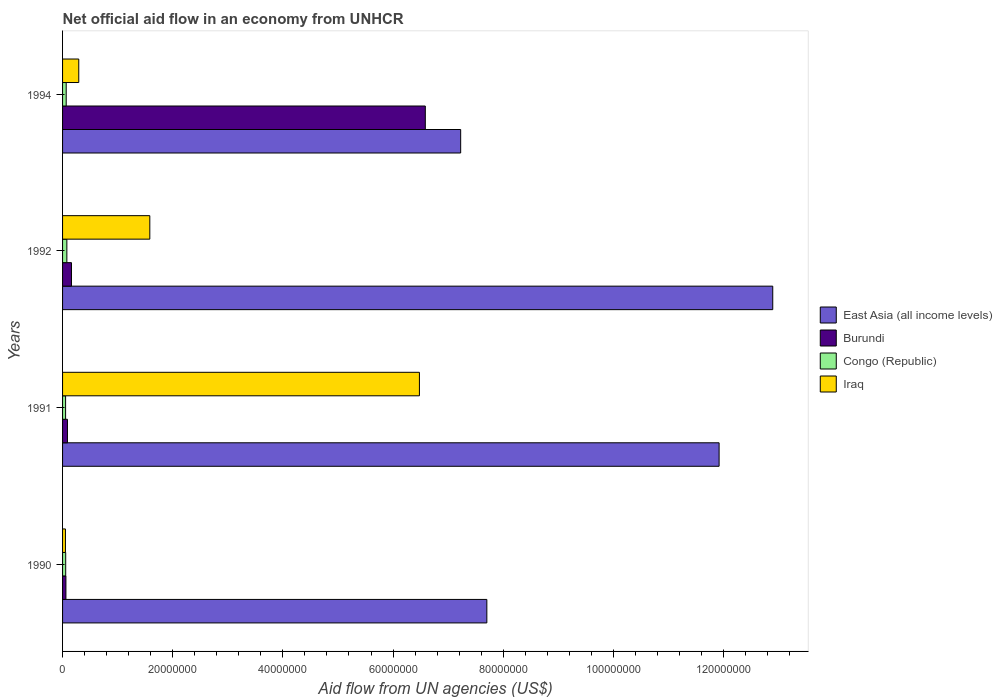How many groups of bars are there?
Offer a very short reply. 4. What is the net official aid flow in Burundi in 1994?
Your answer should be compact. 6.59e+07. Across all years, what is the maximum net official aid flow in Burundi?
Your answer should be very brief. 6.59e+07. Across all years, what is the minimum net official aid flow in East Asia (all income levels)?
Give a very brief answer. 7.23e+07. In which year was the net official aid flow in East Asia (all income levels) maximum?
Keep it short and to the point. 1992. What is the total net official aid flow in Iraq in the graph?
Give a very brief answer. 8.41e+07. What is the difference between the net official aid flow in Iraq in 1990 and that in 1991?
Your response must be concise. -6.43e+07. What is the difference between the net official aid flow in Congo (Republic) in 1994 and the net official aid flow in East Asia (all income levels) in 1991?
Offer a terse response. -1.19e+08. What is the average net official aid flow in Iraq per year?
Keep it short and to the point. 2.10e+07. In the year 1992, what is the difference between the net official aid flow in Iraq and net official aid flow in Burundi?
Your answer should be compact. 1.42e+07. What is the ratio of the net official aid flow in Iraq in 1990 to that in 1991?
Provide a succinct answer. 0.01. Is the net official aid flow in Burundi in 1990 less than that in 1994?
Your answer should be compact. Yes. What is the difference between the highest and the second highest net official aid flow in East Asia (all income levels)?
Ensure brevity in your answer.  9.74e+06. In how many years, is the net official aid flow in Burundi greater than the average net official aid flow in Burundi taken over all years?
Offer a terse response. 1. What does the 2nd bar from the top in 1990 represents?
Give a very brief answer. Congo (Republic). What does the 4th bar from the bottom in 1990 represents?
Your response must be concise. Iraq. How many bars are there?
Provide a short and direct response. 16. Are all the bars in the graph horizontal?
Give a very brief answer. Yes. What is the difference between two consecutive major ticks on the X-axis?
Your answer should be compact. 2.00e+07. How are the legend labels stacked?
Provide a short and direct response. Vertical. What is the title of the graph?
Provide a succinct answer. Net official aid flow in an economy from UNHCR. Does "Isle of Man" appear as one of the legend labels in the graph?
Provide a succinct answer. No. What is the label or title of the X-axis?
Provide a succinct answer. Aid flow from UN agencies (US$). What is the Aid flow from UN agencies (US$) of East Asia (all income levels) in 1990?
Keep it short and to the point. 7.70e+07. What is the Aid flow from UN agencies (US$) of Congo (Republic) in 1990?
Keep it short and to the point. 5.70e+05. What is the Aid flow from UN agencies (US$) of Iraq in 1990?
Your response must be concise. 5.20e+05. What is the Aid flow from UN agencies (US$) in East Asia (all income levels) in 1991?
Provide a succinct answer. 1.19e+08. What is the Aid flow from UN agencies (US$) in Burundi in 1991?
Offer a terse response. 8.90e+05. What is the Aid flow from UN agencies (US$) of Iraq in 1991?
Your response must be concise. 6.48e+07. What is the Aid flow from UN agencies (US$) in East Asia (all income levels) in 1992?
Offer a terse response. 1.29e+08. What is the Aid flow from UN agencies (US$) in Burundi in 1992?
Keep it short and to the point. 1.62e+06. What is the Aid flow from UN agencies (US$) in Congo (Republic) in 1992?
Provide a succinct answer. 7.80e+05. What is the Aid flow from UN agencies (US$) in Iraq in 1992?
Provide a succinct answer. 1.58e+07. What is the Aid flow from UN agencies (US$) in East Asia (all income levels) in 1994?
Provide a succinct answer. 7.23e+07. What is the Aid flow from UN agencies (US$) of Burundi in 1994?
Offer a terse response. 6.59e+07. What is the Aid flow from UN agencies (US$) in Iraq in 1994?
Provide a short and direct response. 2.94e+06. Across all years, what is the maximum Aid flow from UN agencies (US$) in East Asia (all income levels)?
Your answer should be compact. 1.29e+08. Across all years, what is the maximum Aid flow from UN agencies (US$) in Burundi?
Keep it short and to the point. 6.59e+07. Across all years, what is the maximum Aid flow from UN agencies (US$) of Congo (Republic)?
Give a very brief answer. 7.80e+05. Across all years, what is the maximum Aid flow from UN agencies (US$) in Iraq?
Offer a very short reply. 6.48e+07. Across all years, what is the minimum Aid flow from UN agencies (US$) of East Asia (all income levels)?
Make the answer very short. 7.23e+07. Across all years, what is the minimum Aid flow from UN agencies (US$) of Burundi?
Your answer should be compact. 6.10e+05. Across all years, what is the minimum Aid flow from UN agencies (US$) of Iraq?
Make the answer very short. 5.20e+05. What is the total Aid flow from UN agencies (US$) of East Asia (all income levels) in the graph?
Offer a very short reply. 3.97e+08. What is the total Aid flow from UN agencies (US$) of Burundi in the graph?
Give a very brief answer. 6.90e+07. What is the total Aid flow from UN agencies (US$) in Congo (Republic) in the graph?
Provide a succinct answer. 2.56e+06. What is the total Aid flow from UN agencies (US$) of Iraq in the graph?
Provide a short and direct response. 8.41e+07. What is the difference between the Aid flow from UN agencies (US$) of East Asia (all income levels) in 1990 and that in 1991?
Provide a short and direct response. -4.22e+07. What is the difference between the Aid flow from UN agencies (US$) of Burundi in 1990 and that in 1991?
Your response must be concise. -2.80e+05. What is the difference between the Aid flow from UN agencies (US$) in Congo (Republic) in 1990 and that in 1991?
Offer a terse response. 2.00e+04. What is the difference between the Aid flow from UN agencies (US$) of Iraq in 1990 and that in 1991?
Offer a very short reply. -6.43e+07. What is the difference between the Aid flow from UN agencies (US$) in East Asia (all income levels) in 1990 and that in 1992?
Your answer should be very brief. -5.19e+07. What is the difference between the Aid flow from UN agencies (US$) in Burundi in 1990 and that in 1992?
Offer a terse response. -1.01e+06. What is the difference between the Aid flow from UN agencies (US$) of Congo (Republic) in 1990 and that in 1992?
Make the answer very short. -2.10e+05. What is the difference between the Aid flow from UN agencies (US$) in Iraq in 1990 and that in 1992?
Ensure brevity in your answer.  -1.53e+07. What is the difference between the Aid flow from UN agencies (US$) of East Asia (all income levels) in 1990 and that in 1994?
Your response must be concise. 4.75e+06. What is the difference between the Aid flow from UN agencies (US$) of Burundi in 1990 and that in 1994?
Your answer should be compact. -6.52e+07. What is the difference between the Aid flow from UN agencies (US$) of Congo (Republic) in 1990 and that in 1994?
Offer a terse response. -9.00e+04. What is the difference between the Aid flow from UN agencies (US$) of Iraq in 1990 and that in 1994?
Provide a short and direct response. -2.42e+06. What is the difference between the Aid flow from UN agencies (US$) in East Asia (all income levels) in 1991 and that in 1992?
Your answer should be very brief. -9.74e+06. What is the difference between the Aid flow from UN agencies (US$) in Burundi in 1991 and that in 1992?
Ensure brevity in your answer.  -7.30e+05. What is the difference between the Aid flow from UN agencies (US$) in Iraq in 1991 and that in 1992?
Offer a very short reply. 4.90e+07. What is the difference between the Aid flow from UN agencies (US$) of East Asia (all income levels) in 1991 and that in 1994?
Offer a terse response. 4.69e+07. What is the difference between the Aid flow from UN agencies (US$) of Burundi in 1991 and that in 1994?
Provide a short and direct response. -6.50e+07. What is the difference between the Aid flow from UN agencies (US$) in Iraq in 1991 and that in 1994?
Your response must be concise. 6.18e+07. What is the difference between the Aid flow from UN agencies (US$) in East Asia (all income levels) in 1992 and that in 1994?
Your answer should be compact. 5.67e+07. What is the difference between the Aid flow from UN agencies (US$) of Burundi in 1992 and that in 1994?
Your response must be concise. -6.42e+07. What is the difference between the Aid flow from UN agencies (US$) of Iraq in 1992 and that in 1994?
Keep it short and to the point. 1.29e+07. What is the difference between the Aid flow from UN agencies (US$) in East Asia (all income levels) in 1990 and the Aid flow from UN agencies (US$) in Burundi in 1991?
Offer a terse response. 7.61e+07. What is the difference between the Aid flow from UN agencies (US$) of East Asia (all income levels) in 1990 and the Aid flow from UN agencies (US$) of Congo (Republic) in 1991?
Your answer should be compact. 7.65e+07. What is the difference between the Aid flow from UN agencies (US$) in East Asia (all income levels) in 1990 and the Aid flow from UN agencies (US$) in Iraq in 1991?
Your response must be concise. 1.22e+07. What is the difference between the Aid flow from UN agencies (US$) in Burundi in 1990 and the Aid flow from UN agencies (US$) in Iraq in 1991?
Give a very brief answer. -6.42e+07. What is the difference between the Aid flow from UN agencies (US$) in Congo (Republic) in 1990 and the Aid flow from UN agencies (US$) in Iraq in 1991?
Offer a terse response. -6.42e+07. What is the difference between the Aid flow from UN agencies (US$) of East Asia (all income levels) in 1990 and the Aid flow from UN agencies (US$) of Burundi in 1992?
Offer a very short reply. 7.54e+07. What is the difference between the Aid flow from UN agencies (US$) of East Asia (all income levels) in 1990 and the Aid flow from UN agencies (US$) of Congo (Republic) in 1992?
Your answer should be very brief. 7.62e+07. What is the difference between the Aid flow from UN agencies (US$) in East Asia (all income levels) in 1990 and the Aid flow from UN agencies (US$) in Iraq in 1992?
Offer a very short reply. 6.12e+07. What is the difference between the Aid flow from UN agencies (US$) in Burundi in 1990 and the Aid flow from UN agencies (US$) in Congo (Republic) in 1992?
Offer a terse response. -1.70e+05. What is the difference between the Aid flow from UN agencies (US$) in Burundi in 1990 and the Aid flow from UN agencies (US$) in Iraq in 1992?
Offer a very short reply. -1.52e+07. What is the difference between the Aid flow from UN agencies (US$) in Congo (Republic) in 1990 and the Aid flow from UN agencies (US$) in Iraq in 1992?
Offer a very short reply. -1.53e+07. What is the difference between the Aid flow from UN agencies (US$) in East Asia (all income levels) in 1990 and the Aid flow from UN agencies (US$) in Burundi in 1994?
Your answer should be very brief. 1.12e+07. What is the difference between the Aid flow from UN agencies (US$) in East Asia (all income levels) in 1990 and the Aid flow from UN agencies (US$) in Congo (Republic) in 1994?
Keep it short and to the point. 7.64e+07. What is the difference between the Aid flow from UN agencies (US$) of East Asia (all income levels) in 1990 and the Aid flow from UN agencies (US$) of Iraq in 1994?
Offer a terse response. 7.41e+07. What is the difference between the Aid flow from UN agencies (US$) in Burundi in 1990 and the Aid flow from UN agencies (US$) in Congo (Republic) in 1994?
Your answer should be compact. -5.00e+04. What is the difference between the Aid flow from UN agencies (US$) in Burundi in 1990 and the Aid flow from UN agencies (US$) in Iraq in 1994?
Offer a terse response. -2.33e+06. What is the difference between the Aid flow from UN agencies (US$) of Congo (Republic) in 1990 and the Aid flow from UN agencies (US$) of Iraq in 1994?
Offer a very short reply. -2.37e+06. What is the difference between the Aid flow from UN agencies (US$) of East Asia (all income levels) in 1991 and the Aid flow from UN agencies (US$) of Burundi in 1992?
Keep it short and to the point. 1.18e+08. What is the difference between the Aid flow from UN agencies (US$) in East Asia (all income levels) in 1991 and the Aid flow from UN agencies (US$) in Congo (Republic) in 1992?
Your response must be concise. 1.18e+08. What is the difference between the Aid flow from UN agencies (US$) in East Asia (all income levels) in 1991 and the Aid flow from UN agencies (US$) in Iraq in 1992?
Keep it short and to the point. 1.03e+08. What is the difference between the Aid flow from UN agencies (US$) of Burundi in 1991 and the Aid flow from UN agencies (US$) of Congo (Republic) in 1992?
Your answer should be very brief. 1.10e+05. What is the difference between the Aid flow from UN agencies (US$) of Burundi in 1991 and the Aid flow from UN agencies (US$) of Iraq in 1992?
Your response must be concise. -1.50e+07. What is the difference between the Aid flow from UN agencies (US$) in Congo (Republic) in 1991 and the Aid flow from UN agencies (US$) in Iraq in 1992?
Provide a succinct answer. -1.53e+07. What is the difference between the Aid flow from UN agencies (US$) in East Asia (all income levels) in 1991 and the Aid flow from UN agencies (US$) in Burundi in 1994?
Your answer should be very brief. 5.33e+07. What is the difference between the Aid flow from UN agencies (US$) of East Asia (all income levels) in 1991 and the Aid flow from UN agencies (US$) of Congo (Republic) in 1994?
Your answer should be compact. 1.19e+08. What is the difference between the Aid flow from UN agencies (US$) of East Asia (all income levels) in 1991 and the Aid flow from UN agencies (US$) of Iraq in 1994?
Your answer should be very brief. 1.16e+08. What is the difference between the Aid flow from UN agencies (US$) of Burundi in 1991 and the Aid flow from UN agencies (US$) of Iraq in 1994?
Your response must be concise. -2.05e+06. What is the difference between the Aid flow from UN agencies (US$) in Congo (Republic) in 1991 and the Aid flow from UN agencies (US$) in Iraq in 1994?
Provide a short and direct response. -2.39e+06. What is the difference between the Aid flow from UN agencies (US$) in East Asia (all income levels) in 1992 and the Aid flow from UN agencies (US$) in Burundi in 1994?
Provide a succinct answer. 6.31e+07. What is the difference between the Aid flow from UN agencies (US$) in East Asia (all income levels) in 1992 and the Aid flow from UN agencies (US$) in Congo (Republic) in 1994?
Provide a short and direct response. 1.28e+08. What is the difference between the Aid flow from UN agencies (US$) of East Asia (all income levels) in 1992 and the Aid flow from UN agencies (US$) of Iraq in 1994?
Make the answer very short. 1.26e+08. What is the difference between the Aid flow from UN agencies (US$) of Burundi in 1992 and the Aid flow from UN agencies (US$) of Congo (Republic) in 1994?
Your response must be concise. 9.60e+05. What is the difference between the Aid flow from UN agencies (US$) in Burundi in 1992 and the Aid flow from UN agencies (US$) in Iraq in 1994?
Keep it short and to the point. -1.32e+06. What is the difference between the Aid flow from UN agencies (US$) of Congo (Republic) in 1992 and the Aid flow from UN agencies (US$) of Iraq in 1994?
Offer a terse response. -2.16e+06. What is the average Aid flow from UN agencies (US$) in East Asia (all income levels) per year?
Your answer should be very brief. 9.94e+07. What is the average Aid flow from UN agencies (US$) in Burundi per year?
Make the answer very short. 1.72e+07. What is the average Aid flow from UN agencies (US$) in Congo (Republic) per year?
Your answer should be very brief. 6.40e+05. What is the average Aid flow from UN agencies (US$) of Iraq per year?
Your response must be concise. 2.10e+07. In the year 1990, what is the difference between the Aid flow from UN agencies (US$) in East Asia (all income levels) and Aid flow from UN agencies (US$) in Burundi?
Keep it short and to the point. 7.64e+07. In the year 1990, what is the difference between the Aid flow from UN agencies (US$) of East Asia (all income levels) and Aid flow from UN agencies (US$) of Congo (Republic)?
Make the answer very short. 7.65e+07. In the year 1990, what is the difference between the Aid flow from UN agencies (US$) in East Asia (all income levels) and Aid flow from UN agencies (US$) in Iraq?
Provide a succinct answer. 7.65e+07. In the year 1990, what is the difference between the Aid flow from UN agencies (US$) of Burundi and Aid flow from UN agencies (US$) of Congo (Republic)?
Keep it short and to the point. 4.00e+04. In the year 1990, what is the difference between the Aid flow from UN agencies (US$) in Burundi and Aid flow from UN agencies (US$) in Iraq?
Keep it short and to the point. 9.00e+04. In the year 1991, what is the difference between the Aid flow from UN agencies (US$) in East Asia (all income levels) and Aid flow from UN agencies (US$) in Burundi?
Your answer should be very brief. 1.18e+08. In the year 1991, what is the difference between the Aid flow from UN agencies (US$) in East Asia (all income levels) and Aid flow from UN agencies (US$) in Congo (Republic)?
Give a very brief answer. 1.19e+08. In the year 1991, what is the difference between the Aid flow from UN agencies (US$) in East Asia (all income levels) and Aid flow from UN agencies (US$) in Iraq?
Provide a succinct answer. 5.44e+07. In the year 1991, what is the difference between the Aid flow from UN agencies (US$) in Burundi and Aid flow from UN agencies (US$) in Iraq?
Make the answer very short. -6.39e+07. In the year 1991, what is the difference between the Aid flow from UN agencies (US$) in Congo (Republic) and Aid flow from UN agencies (US$) in Iraq?
Your answer should be very brief. -6.42e+07. In the year 1992, what is the difference between the Aid flow from UN agencies (US$) of East Asia (all income levels) and Aid flow from UN agencies (US$) of Burundi?
Ensure brevity in your answer.  1.27e+08. In the year 1992, what is the difference between the Aid flow from UN agencies (US$) in East Asia (all income levels) and Aid flow from UN agencies (US$) in Congo (Republic)?
Your answer should be compact. 1.28e+08. In the year 1992, what is the difference between the Aid flow from UN agencies (US$) of East Asia (all income levels) and Aid flow from UN agencies (US$) of Iraq?
Provide a short and direct response. 1.13e+08. In the year 1992, what is the difference between the Aid flow from UN agencies (US$) in Burundi and Aid flow from UN agencies (US$) in Congo (Republic)?
Provide a succinct answer. 8.40e+05. In the year 1992, what is the difference between the Aid flow from UN agencies (US$) in Burundi and Aid flow from UN agencies (US$) in Iraq?
Your answer should be compact. -1.42e+07. In the year 1992, what is the difference between the Aid flow from UN agencies (US$) of Congo (Republic) and Aid flow from UN agencies (US$) of Iraq?
Your response must be concise. -1.51e+07. In the year 1994, what is the difference between the Aid flow from UN agencies (US$) in East Asia (all income levels) and Aid flow from UN agencies (US$) in Burundi?
Make the answer very short. 6.42e+06. In the year 1994, what is the difference between the Aid flow from UN agencies (US$) in East Asia (all income levels) and Aid flow from UN agencies (US$) in Congo (Republic)?
Offer a terse response. 7.16e+07. In the year 1994, what is the difference between the Aid flow from UN agencies (US$) of East Asia (all income levels) and Aid flow from UN agencies (US$) of Iraq?
Provide a succinct answer. 6.93e+07. In the year 1994, what is the difference between the Aid flow from UN agencies (US$) of Burundi and Aid flow from UN agencies (US$) of Congo (Republic)?
Offer a very short reply. 6.52e+07. In the year 1994, what is the difference between the Aid flow from UN agencies (US$) in Burundi and Aid flow from UN agencies (US$) in Iraq?
Ensure brevity in your answer.  6.29e+07. In the year 1994, what is the difference between the Aid flow from UN agencies (US$) of Congo (Republic) and Aid flow from UN agencies (US$) of Iraq?
Provide a short and direct response. -2.28e+06. What is the ratio of the Aid flow from UN agencies (US$) in East Asia (all income levels) in 1990 to that in 1991?
Your response must be concise. 0.65. What is the ratio of the Aid flow from UN agencies (US$) of Burundi in 1990 to that in 1991?
Provide a short and direct response. 0.69. What is the ratio of the Aid flow from UN agencies (US$) of Congo (Republic) in 1990 to that in 1991?
Make the answer very short. 1.04. What is the ratio of the Aid flow from UN agencies (US$) of Iraq in 1990 to that in 1991?
Give a very brief answer. 0.01. What is the ratio of the Aid flow from UN agencies (US$) in East Asia (all income levels) in 1990 to that in 1992?
Provide a succinct answer. 0.6. What is the ratio of the Aid flow from UN agencies (US$) in Burundi in 1990 to that in 1992?
Give a very brief answer. 0.38. What is the ratio of the Aid flow from UN agencies (US$) of Congo (Republic) in 1990 to that in 1992?
Offer a terse response. 0.73. What is the ratio of the Aid flow from UN agencies (US$) of Iraq in 1990 to that in 1992?
Offer a terse response. 0.03. What is the ratio of the Aid flow from UN agencies (US$) in East Asia (all income levels) in 1990 to that in 1994?
Ensure brevity in your answer.  1.07. What is the ratio of the Aid flow from UN agencies (US$) of Burundi in 1990 to that in 1994?
Your answer should be very brief. 0.01. What is the ratio of the Aid flow from UN agencies (US$) in Congo (Republic) in 1990 to that in 1994?
Offer a terse response. 0.86. What is the ratio of the Aid flow from UN agencies (US$) of Iraq in 1990 to that in 1994?
Ensure brevity in your answer.  0.18. What is the ratio of the Aid flow from UN agencies (US$) in East Asia (all income levels) in 1991 to that in 1992?
Offer a very short reply. 0.92. What is the ratio of the Aid flow from UN agencies (US$) of Burundi in 1991 to that in 1992?
Provide a short and direct response. 0.55. What is the ratio of the Aid flow from UN agencies (US$) of Congo (Republic) in 1991 to that in 1992?
Your answer should be very brief. 0.71. What is the ratio of the Aid flow from UN agencies (US$) of Iraq in 1991 to that in 1992?
Give a very brief answer. 4.09. What is the ratio of the Aid flow from UN agencies (US$) of East Asia (all income levels) in 1991 to that in 1994?
Provide a succinct answer. 1.65. What is the ratio of the Aid flow from UN agencies (US$) in Burundi in 1991 to that in 1994?
Your answer should be very brief. 0.01. What is the ratio of the Aid flow from UN agencies (US$) of Congo (Republic) in 1991 to that in 1994?
Offer a very short reply. 0.83. What is the ratio of the Aid flow from UN agencies (US$) in Iraq in 1991 to that in 1994?
Offer a terse response. 22.04. What is the ratio of the Aid flow from UN agencies (US$) in East Asia (all income levels) in 1992 to that in 1994?
Provide a short and direct response. 1.78. What is the ratio of the Aid flow from UN agencies (US$) in Burundi in 1992 to that in 1994?
Provide a short and direct response. 0.02. What is the ratio of the Aid flow from UN agencies (US$) of Congo (Republic) in 1992 to that in 1994?
Your response must be concise. 1.18. What is the ratio of the Aid flow from UN agencies (US$) in Iraq in 1992 to that in 1994?
Offer a terse response. 5.39. What is the difference between the highest and the second highest Aid flow from UN agencies (US$) of East Asia (all income levels)?
Give a very brief answer. 9.74e+06. What is the difference between the highest and the second highest Aid flow from UN agencies (US$) in Burundi?
Give a very brief answer. 6.42e+07. What is the difference between the highest and the second highest Aid flow from UN agencies (US$) in Congo (Republic)?
Keep it short and to the point. 1.20e+05. What is the difference between the highest and the second highest Aid flow from UN agencies (US$) of Iraq?
Give a very brief answer. 4.90e+07. What is the difference between the highest and the lowest Aid flow from UN agencies (US$) of East Asia (all income levels)?
Your response must be concise. 5.67e+07. What is the difference between the highest and the lowest Aid flow from UN agencies (US$) in Burundi?
Make the answer very short. 6.52e+07. What is the difference between the highest and the lowest Aid flow from UN agencies (US$) of Iraq?
Your answer should be compact. 6.43e+07. 